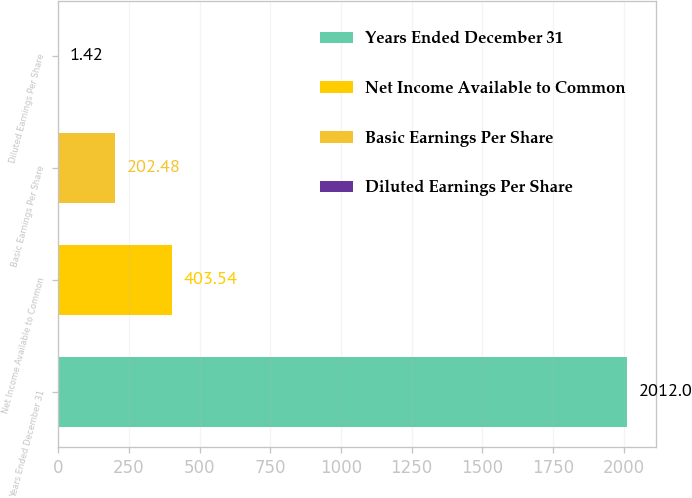<chart> <loc_0><loc_0><loc_500><loc_500><bar_chart><fcel>Years Ended December 31<fcel>Net Income Available to Common<fcel>Basic Earnings Per Share<fcel>Diluted Earnings Per Share<nl><fcel>2012<fcel>403.54<fcel>202.48<fcel>1.42<nl></chart> 